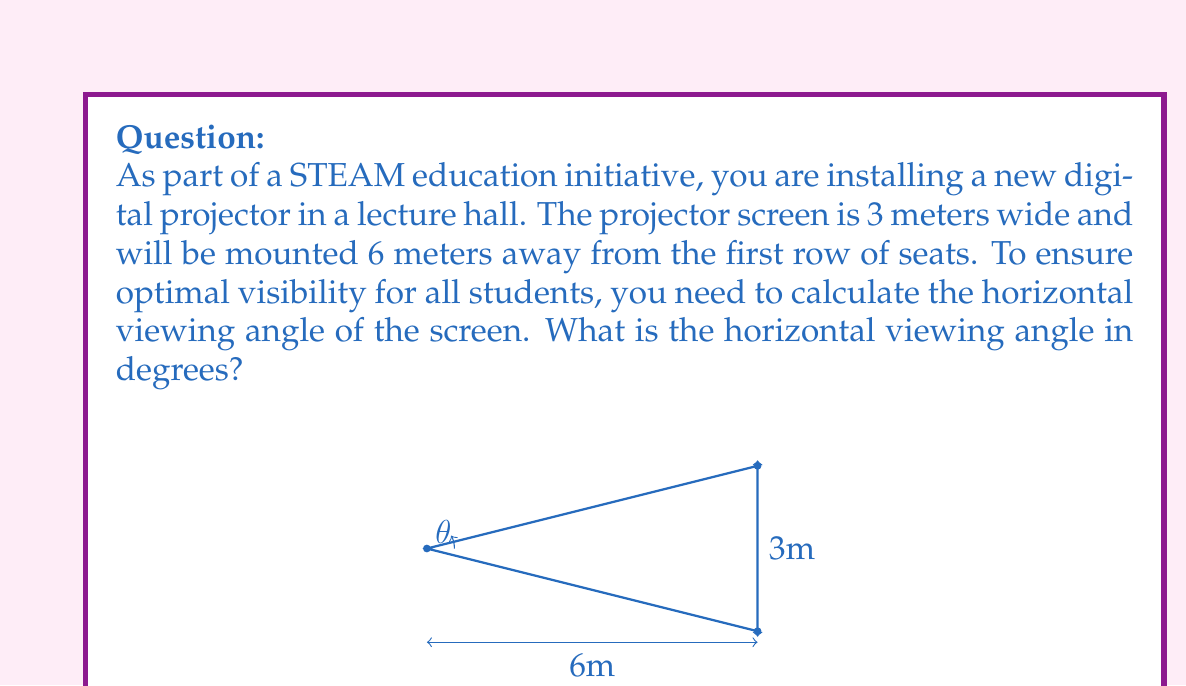Could you help me with this problem? To solve this problem, we can use basic trigonometry. Let's break it down step-by-step:

1) First, we need to identify the triangle formed by the projector screen and the viewing point. In this case, we have a right triangle where:
   - The base is the distance from the first row to the screen (6 meters)
   - Half of the screen width forms the opposite side (1.5 meters, as the full width is 3 meters)
   - The angle we're looking for is formed at the viewing point

2) We can use the tangent function to find half of the viewing angle. Let's call this angle $\theta/2$:

   $$\tan(\theta/2) = \frac{\text{opposite}}{\text{adjacent}} = \frac{1.5}{6}$$

3) To find $\theta/2$, we need to use the inverse tangent (arctangent) function:

   $$\theta/2 = \arctan(\frac{1.5}{6})$$

4) We can calculate this:

   $$\theta/2 = \arctan(0.25) \approx 14.04^\circ$$

5) Since this is half of the total viewing angle, we need to double it to get the full angle:

   $$\theta = 2 * 14.04^\circ = 28.08^\circ$$

Therefore, the horizontal viewing angle is approximately 28.08°.

This calculation helps ensure that the digital projector screen is positioned for optimal visibility, contributing to an enhanced learning experience in STEAM education programs.
Answer: The horizontal viewing angle is approximately $28.08^\circ$. 